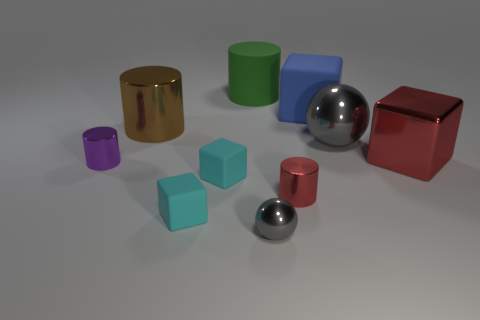Is the color of the tiny shiny sphere the same as the large ball?
Provide a short and direct response. Yes. Does the rubber block that is behind the purple metal thing have the same size as the red shiny cylinder?
Your response must be concise. No. What material is the large green thing that is the same shape as the tiny red shiny thing?
Keep it short and to the point. Rubber. Does the small sphere have the same material as the gray object behind the large red block?
Make the answer very short. Yes. What shape is the metallic object to the left of the big cylinder that is in front of the green object?
Your response must be concise. Cylinder. How many big objects are either brown rubber objects or purple cylinders?
Your answer should be compact. 0. How many other big brown things are the same shape as the big brown object?
Your answer should be very brief. 0. Do the tiny red metal thing and the large rubber object that is to the left of the small gray shiny ball have the same shape?
Your answer should be very brief. Yes. How many big red metal blocks are behind the green matte cylinder?
Make the answer very short. 0. Is there a gray metallic sphere of the same size as the green cylinder?
Your answer should be compact. Yes. 